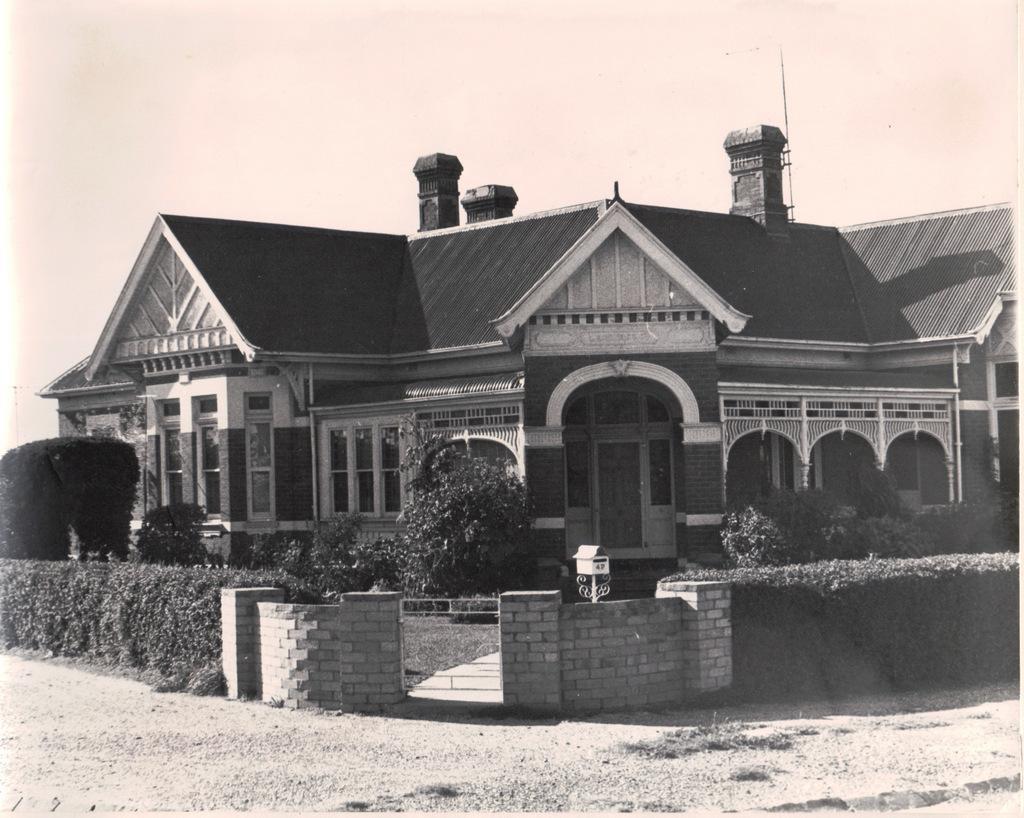In one or two sentences, can you explain what this image depicts? In the foreground of this black and white image, there is a house, few plants, wall, gate, sky and the ground on the bottom. 